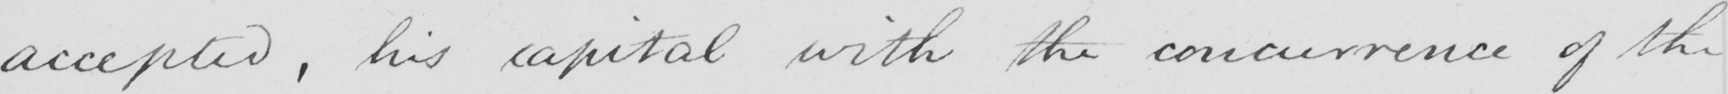Transcribe the text shown in this historical manuscript line. accepted , his capital with the concurrence of the 